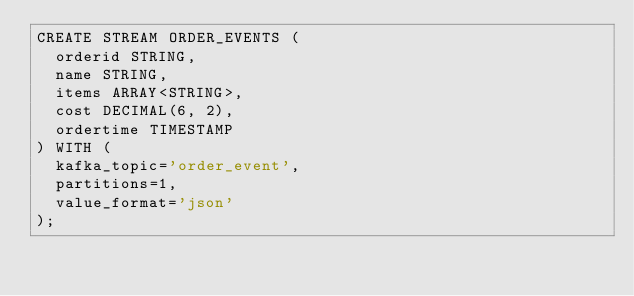Convert code to text. <code><loc_0><loc_0><loc_500><loc_500><_SQL_>CREATE STREAM ORDER_EVENTS (
  orderid STRING, 
  name STRING, 
  items ARRAY<STRING>,
  cost DECIMAL(6, 2),
  ordertime TIMESTAMP
) WITH (
  kafka_topic='order_event', 
  partitions=1,
  value_format='json'
);
</code> 